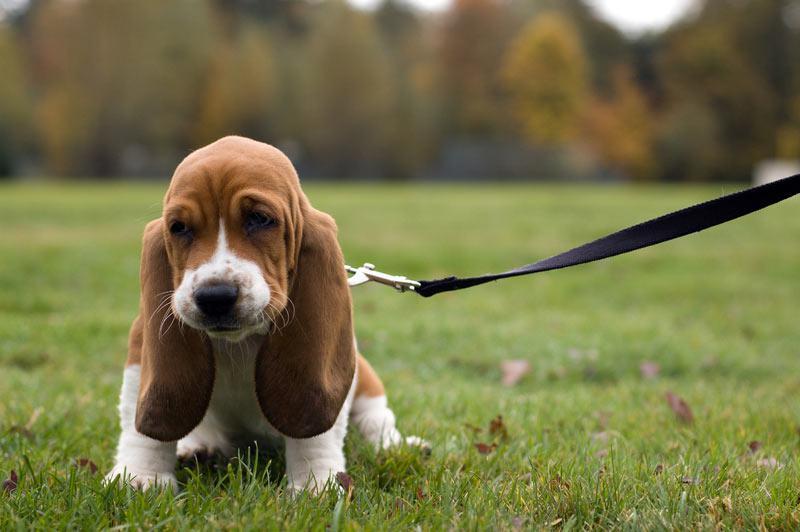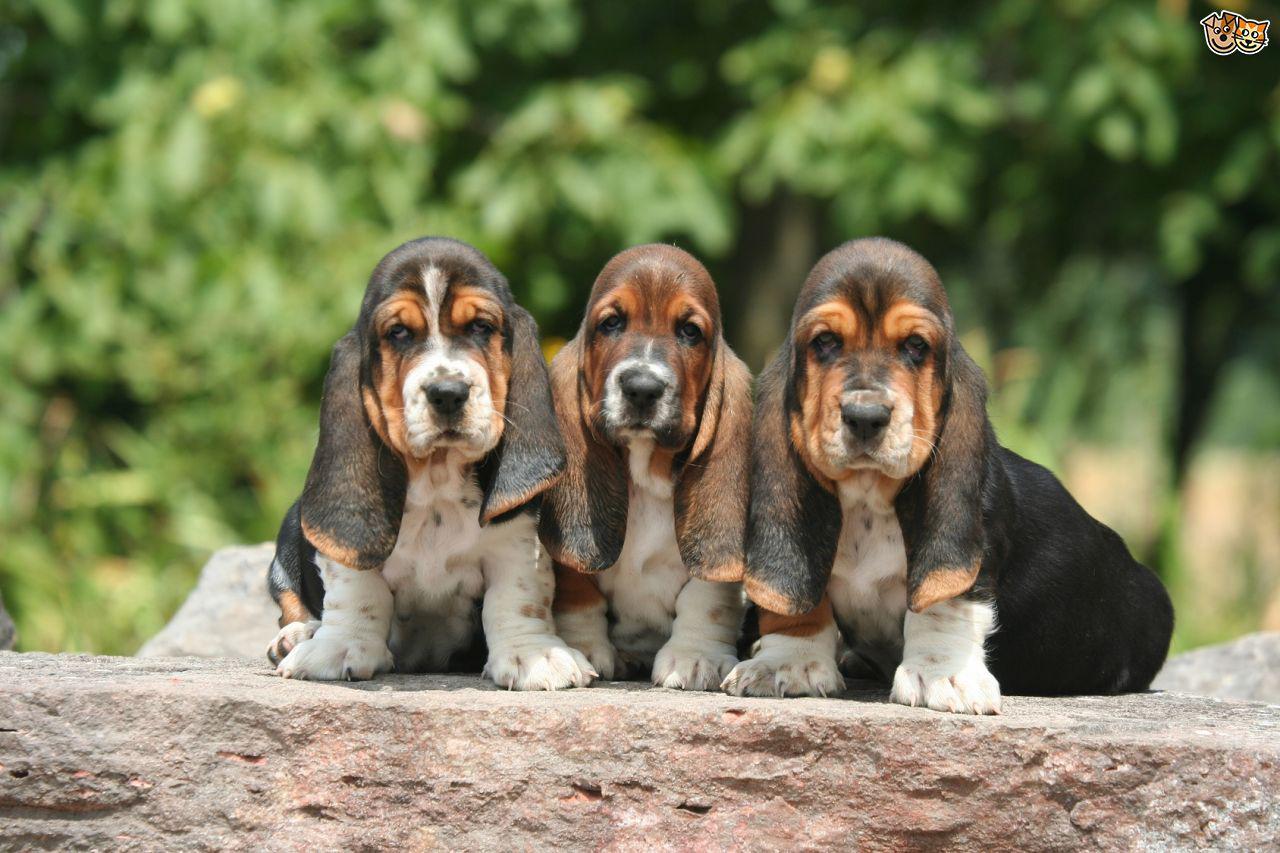The first image is the image on the left, the second image is the image on the right. Considering the images on both sides, is "One of the image shows a single dog on a leash and the other shows a group of at least three dogs." valid? Answer yes or no. Yes. The first image is the image on the left, the second image is the image on the right. Assess this claim about the two images: "In total, we have more than two dogs here.". Correct or not? Answer yes or no. Yes. 